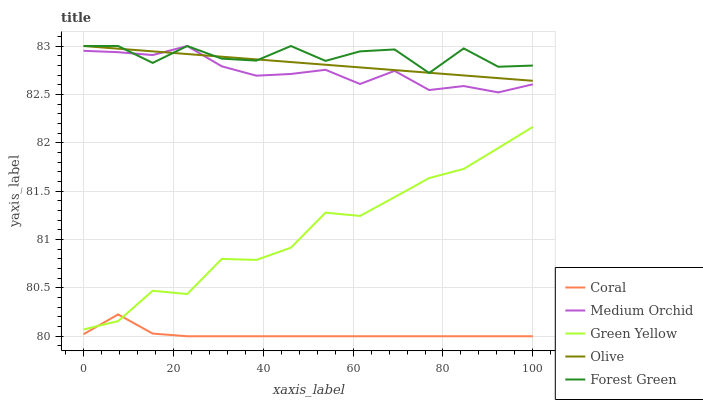Does Coral have the minimum area under the curve?
Answer yes or no. Yes. Does Forest Green have the maximum area under the curve?
Answer yes or no. Yes. Does Medium Orchid have the minimum area under the curve?
Answer yes or no. No. Does Medium Orchid have the maximum area under the curve?
Answer yes or no. No. Is Olive the smoothest?
Answer yes or no. Yes. Is Forest Green the roughest?
Answer yes or no. Yes. Is Coral the smoothest?
Answer yes or no. No. Is Coral the roughest?
Answer yes or no. No. Does Coral have the lowest value?
Answer yes or no. Yes. Does Medium Orchid have the lowest value?
Answer yes or no. No. Does Forest Green have the highest value?
Answer yes or no. Yes. Does Coral have the highest value?
Answer yes or no. No. Is Coral less than Forest Green?
Answer yes or no. Yes. Is Olive greater than Green Yellow?
Answer yes or no. Yes. Does Coral intersect Green Yellow?
Answer yes or no. Yes. Is Coral less than Green Yellow?
Answer yes or no. No. Is Coral greater than Green Yellow?
Answer yes or no. No. Does Coral intersect Forest Green?
Answer yes or no. No. 